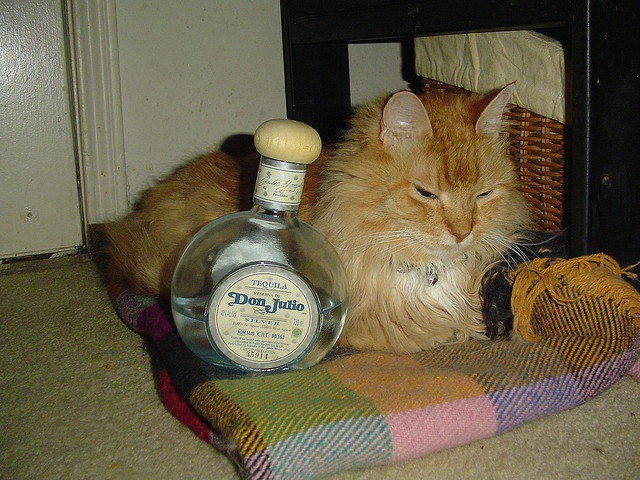Describe the objects in this image and their specific colors. I can see cat in gray, tan, and olive tones and bottle in gray, darkgray, darkgreen, and beige tones in this image. 